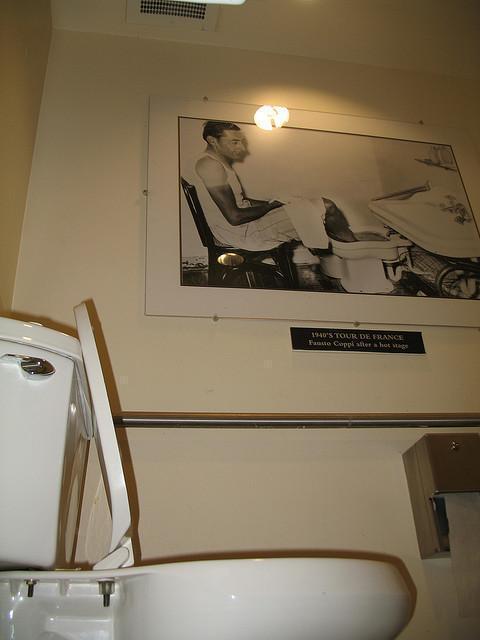What kind of athlete was the man in the black and white image most likely?
From the following set of four choices, select the accurate answer to respond to the question.
Options: Footballer, swimmer, runner, cyclist. Cyclist. 